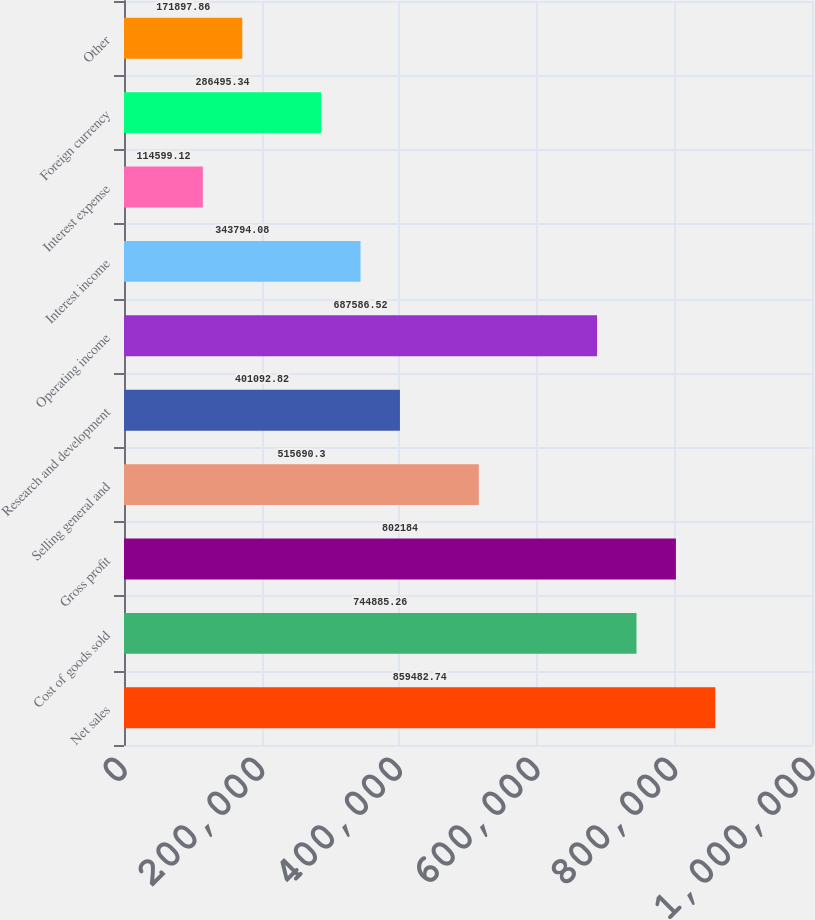Convert chart to OTSL. <chart><loc_0><loc_0><loc_500><loc_500><bar_chart><fcel>Net sales<fcel>Cost of goods sold<fcel>Gross profit<fcel>Selling general and<fcel>Research and development<fcel>Operating income<fcel>Interest income<fcel>Interest expense<fcel>Foreign currency<fcel>Other<nl><fcel>859483<fcel>744885<fcel>802184<fcel>515690<fcel>401093<fcel>687587<fcel>343794<fcel>114599<fcel>286495<fcel>171898<nl></chart> 